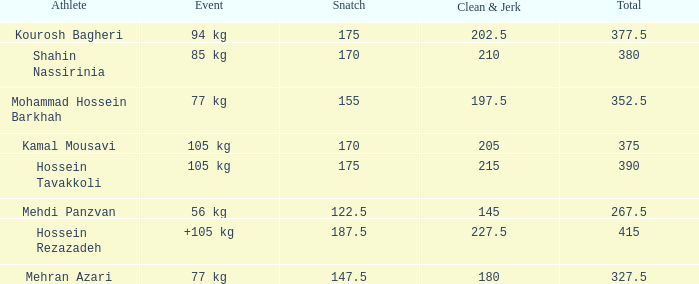How many snatches were there with a total of 267.5? 0.0. 